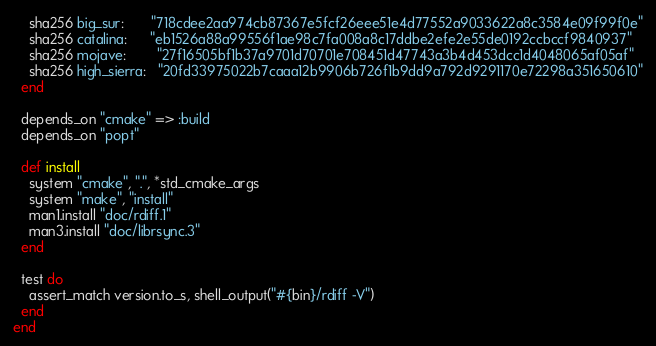Convert code to text. <code><loc_0><loc_0><loc_500><loc_500><_Ruby_>    sha256 big_sur:       "718cdee2aa974cb87367e5fcf26eee51e4d77552a9033622a8c3584e09f99f0e"
    sha256 catalina:      "eb1526a88a99556f1ae98c7fa008a8c17ddbe2efe2e55de0192ccbccf9840937"
    sha256 mojave:        "27f16505bf1b37a9701d70701e708451d47743a3b4d453dcc1d4048065af05af"
    sha256 high_sierra:   "20fd33975022b7caaa12b9906b726f1b9dd9a792d9291170e72298a351650610"
  end

  depends_on "cmake" => :build
  depends_on "popt"

  def install
    system "cmake", ".", *std_cmake_args
    system "make", "install"
    man1.install "doc/rdiff.1"
    man3.install "doc/librsync.3"
  end

  test do
    assert_match version.to_s, shell_output("#{bin}/rdiff -V")
  end
end
</code> 